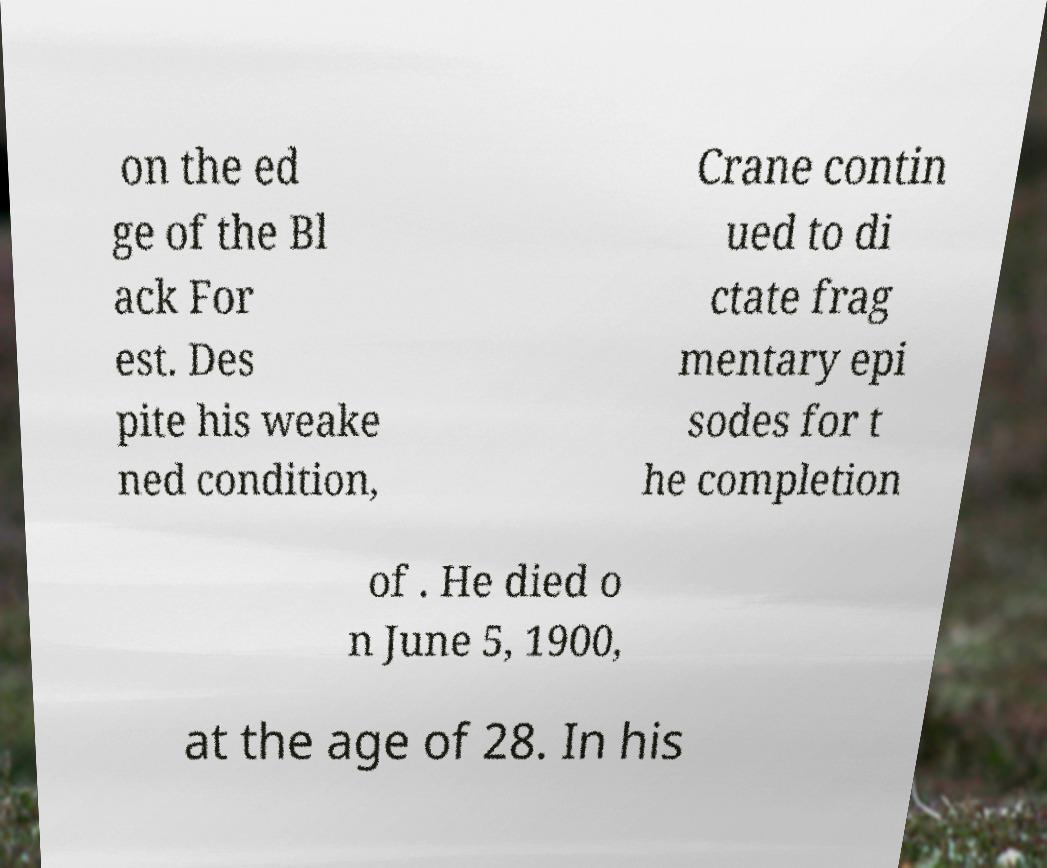I need the written content from this picture converted into text. Can you do that? on the ed ge of the Bl ack For est. Des pite his weake ned condition, Crane contin ued to di ctate frag mentary epi sodes for t he completion of . He died o n June 5, 1900, at the age of 28. In his 